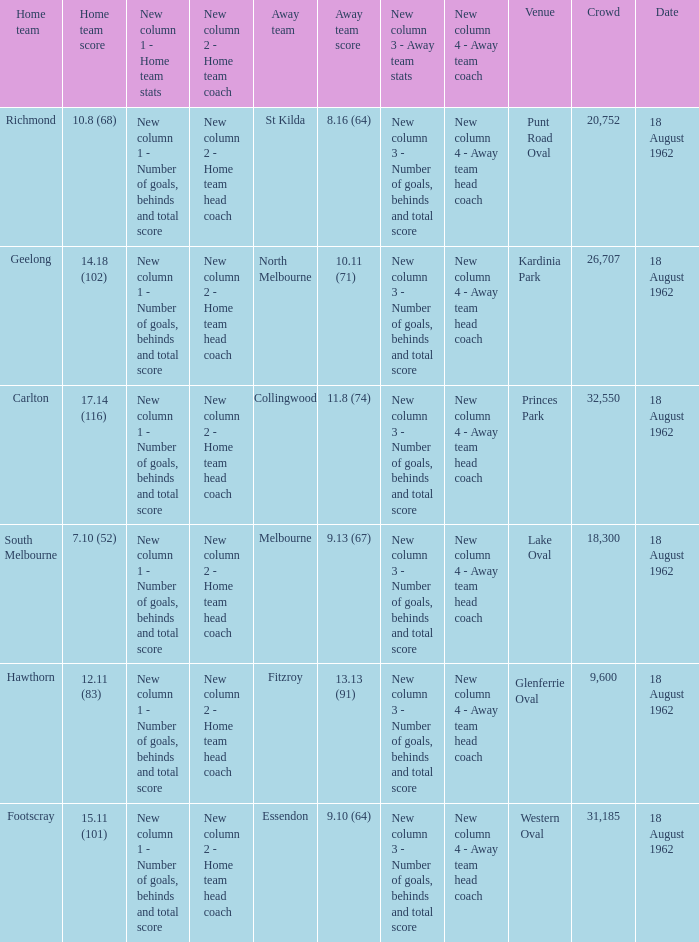11 (83) was the spectator count more than 31,185? None. 